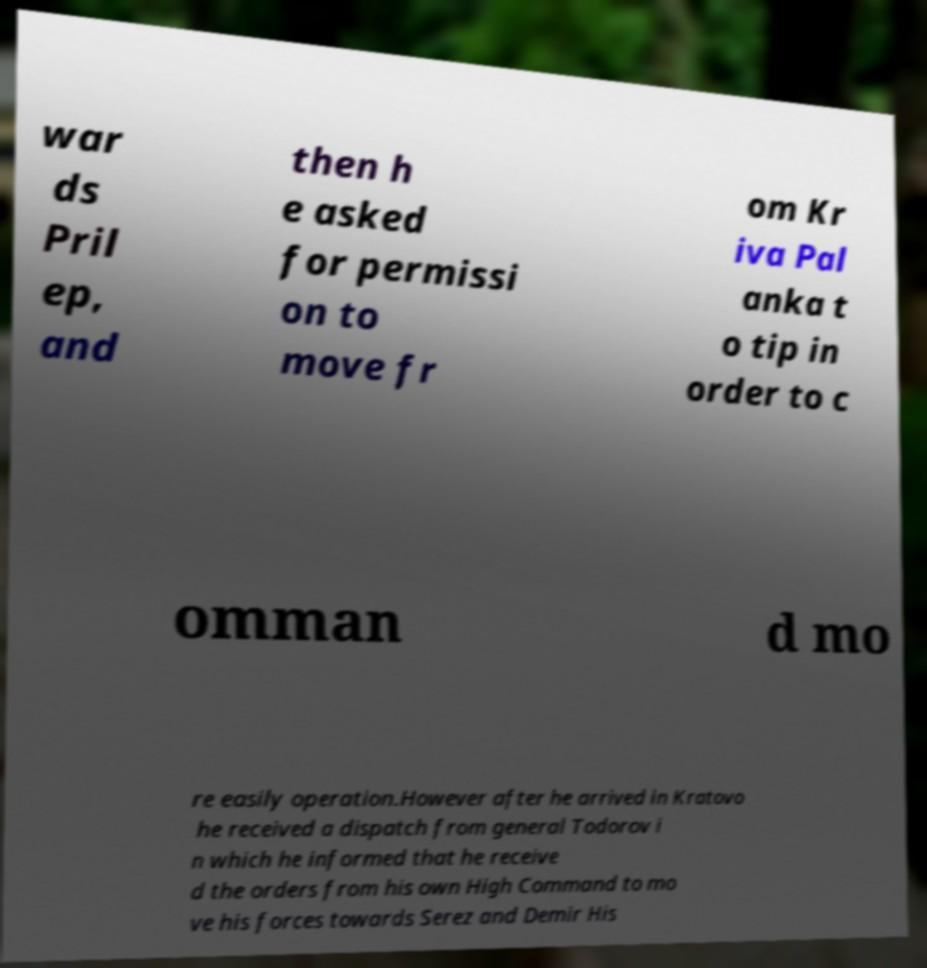Please identify and transcribe the text found in this image. war ds Pril ep, and then h e asked for permissi on to move fr om Kr iva Pal anka t o tip in order to c omman d mo re easily operation.However after he arrived in Kratovo he received a dispatch from general Todorov i n which he informed that he receive d the orders from his own High Command to mo ve his forces towards Serez and Demir His 